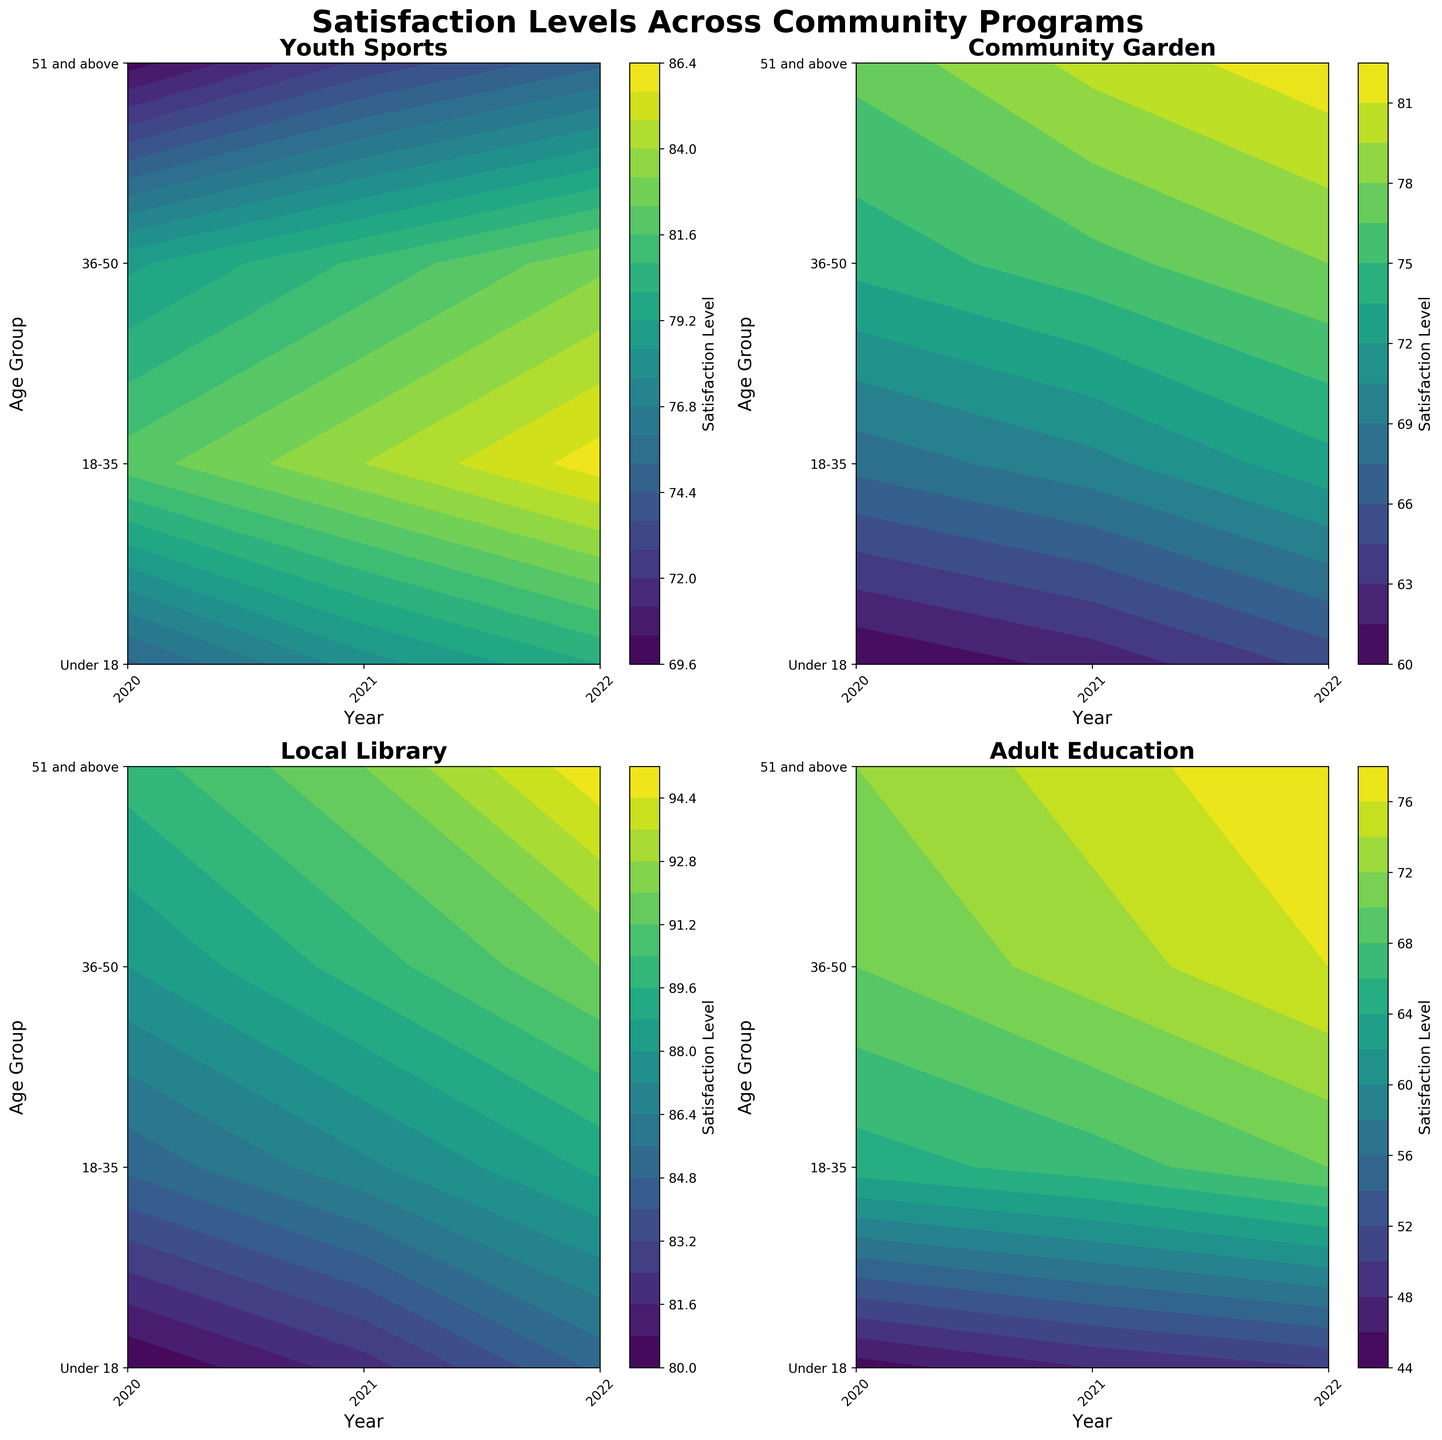Which program shows the highest satisfaction level in 2022 for the 51 and above age group? Look at the 2022 contour for the 51 and above age group for each subplot. Identify the contour with the highest value.
Answer: Local Library What is the satisfaction level trend for the Youth Sports program from 2020 to 2022 for the Under 18 age group? Examine the contour for the Youth Sports subplot and follow the levels for the Under 18 row from 2020 to 2022. Notice the increase in levels.
Answer: Increasing Which age group consistently shows the lowest satisfaction level for Adult Education across all years? Check the contour for the Adult Education subplot and identify the row (age group) with consistently low levels for all years.
Answer: Under 18 Compare the satisfaction levels for the Community Garden and Local Library programs in 2021 for the 18-35 age group. Which program has higher satisfaction? Look at both Community Garden and Local Library subplots, focusing on the 18-35 row for the year 2021. Compare the levels.
Answer: Local Library Which program exhibited the most notable increase in satisfaction levels from 2020 to 2022 for the 18-35 age group? Compare the 18-35 row levels in 2020 and 2022 across all subplots. The program with the largest increase is identified.
Answer: Community Garden What is the overall trend in satisfaction levels across all programs for the 36-50 age group from 2020 to 2022? Examine the 36-50 row for each program subplot from 2020 to 2022 and observe general patterns.
Answer: Increasing What is the range of satisfaction levels for the Local Library program in 2020 across all age groups? Check the 2020 column in the Local Library subplot and note the lowest and highest levels among all age groups.
Answer: 80 to 90 Is there any program where the 51 and above age group shows a decrease in satisfaction level from 2020 to 2021? Inspect the contour for each subplot, specifically looking at the 51 and above row between 2020 and 2021. Look for any decrease.
Answer: No 